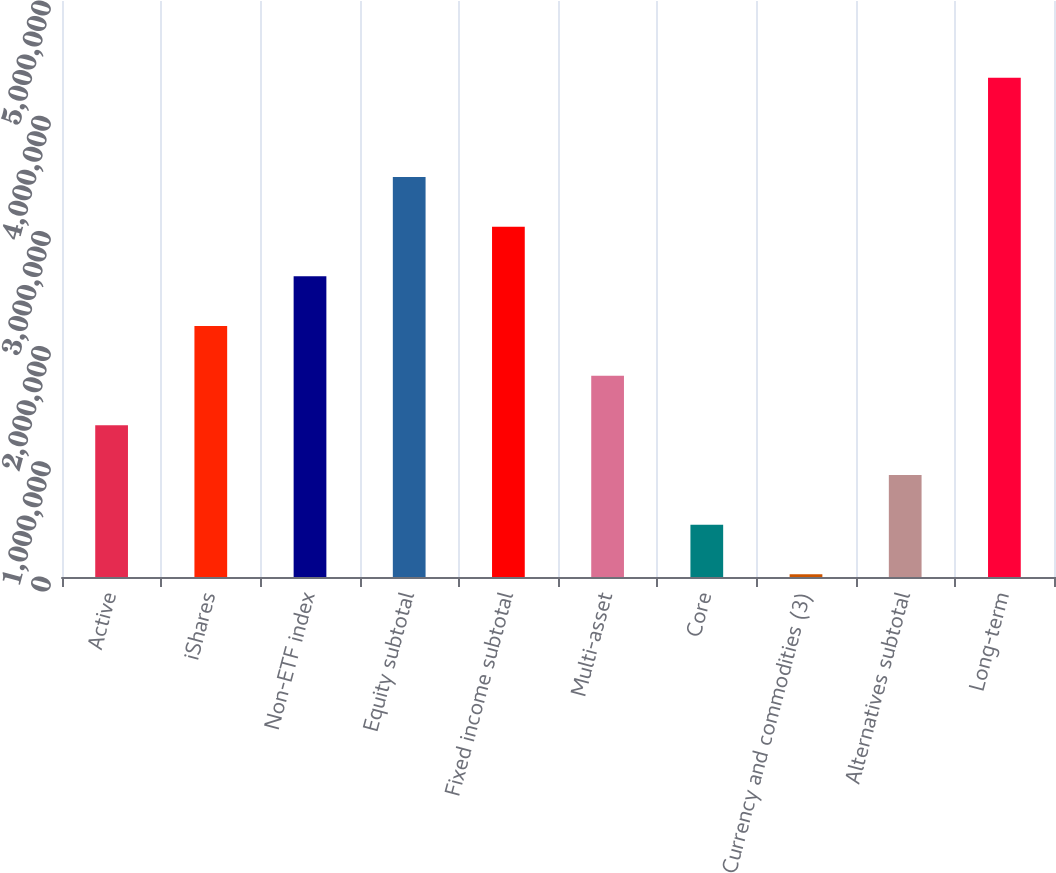Convert chart. <chart><loc_0><loc_0><loc_500><loc_500><bar_chart><fcel>Active<fcel>iShares<fcel>Non-ETF index<fcel>Equity subtotal<fcel>Fixed income subtotal<fcel>Multi-asset<fcel>Core<fcel>Currency and commodities (3)<fcel>Alternatives subtotal<fcel>Long-term<nl><fcel>1.31642e+06<fcel>2.17854e+06<fcel>2.6096e+06<fcel>3.47172e+06<fcel>3.04066e+06<fcel>1.74748e+06<fcel>454295<fcel>23234<fcel>885355<fcel>4.33384e+06<nl></chart> 